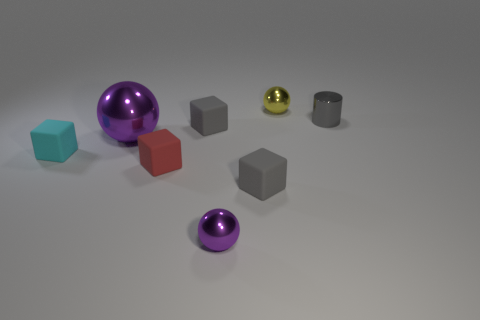There is a gray block behind the cyan rubber cube; is it the same size as the purple sphere that is behind the small red block?
Your response must be concise. No. Are there any small cyan objects made of the same material as the tiny red cube?
Offer a very short reply. Yes. What is the shape of the small yellow thing?
Keep it short and to the point. Sphere. What is the shape of the small gray object that is in front of the block that is to the left of the big purple object?
Give a very brief answer. Cube. What number of other objects are there of the same shape as the small cyan object?
Your answer should be very brief. 3. What size is the purple sphere behind the ball that is in front of the cyan block?
Your response must be concise. Large. Are there any large red matte things?
Your answer should be compact. No. What number of metal objects are left of the tiny metallic object that is right of the tiny yellow ball?
Provide a short and direct response. 3. What shape is the gray thing that is in front of the large purple ball?
Your answer should be very brief. Cube. The small thing that is to the right of the tiny sphere to the right of the ball in front of the large metal ball is made of what material?
Make the answer very short. Metal. 